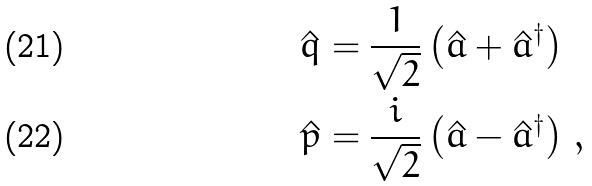<formula> <loc_0><loc_0><loc_500><loc_500>\hat { q } & = \frac { 1 } { \sqrt { 2 } } \left ( \hat { a } + \hat { a } ^ { \dagger } \right ) \\ \hat { p } & = \frac { i } { \sqrt { 2 } } \left ( \hat { a } - \hat { a } ^ { \dagger } \right ) \, ,</formula> 